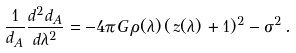Convert formula to latex. <formula><loc_0><loc_0><loc_500><loc_500>\frac { 1 } { d _ { A } } \frac { d ^ { 2 } d _ { A } } { d \lambda ^ { 2 } } = - 4 \pi G \, \rho ( \lambda ) \, ( \, z ( \lambda ) \, + 1 ) ^ { 2 } - \sigma ^ { 2 } \, .</formula> 